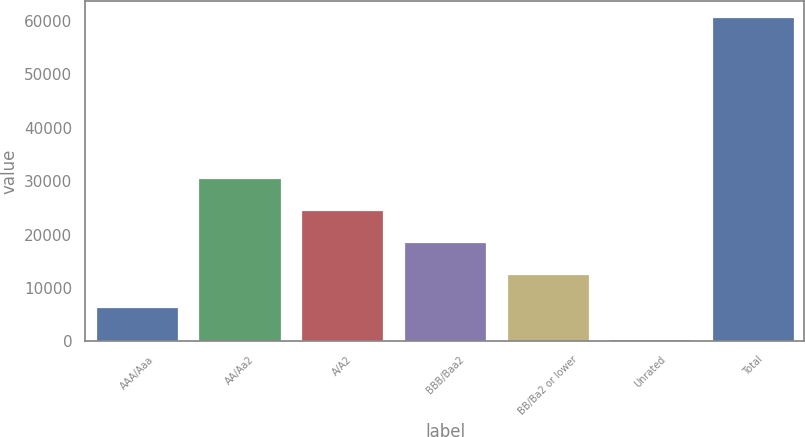Convert chart to OTSL. <chart><loc_0><loc_0><loc_500><loc_500><bar_chart><fcel>AAA/Aaa<fcel>AA/Aa2<fcel>A/A2<fcel>BBB/Baa2<fcel>BB/Ba2 or lower<fcel>Unrated<fcel>Total<nl><fcel>6510.2<fcel>30611<fcel>24585.8<fcel>18560.6<fcel>12535.4<fcel>485<fcel>60737<nl></chart> 